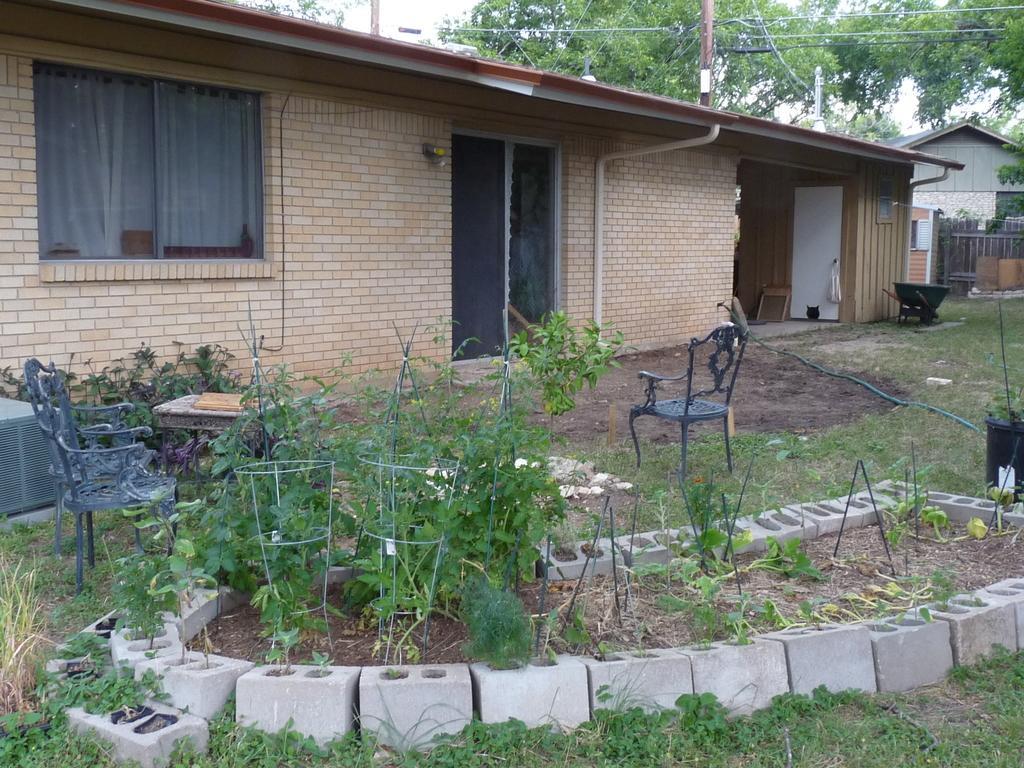In one or two sentences, can you explain what this image depicts? In this image, we can see two houses with walls. Here there is a window, curtains, door, pole. At the bottom, there are few plants, stands, chairs, some objects, pipe. Top of the image, there are so many trees, poles with wire and sky. 